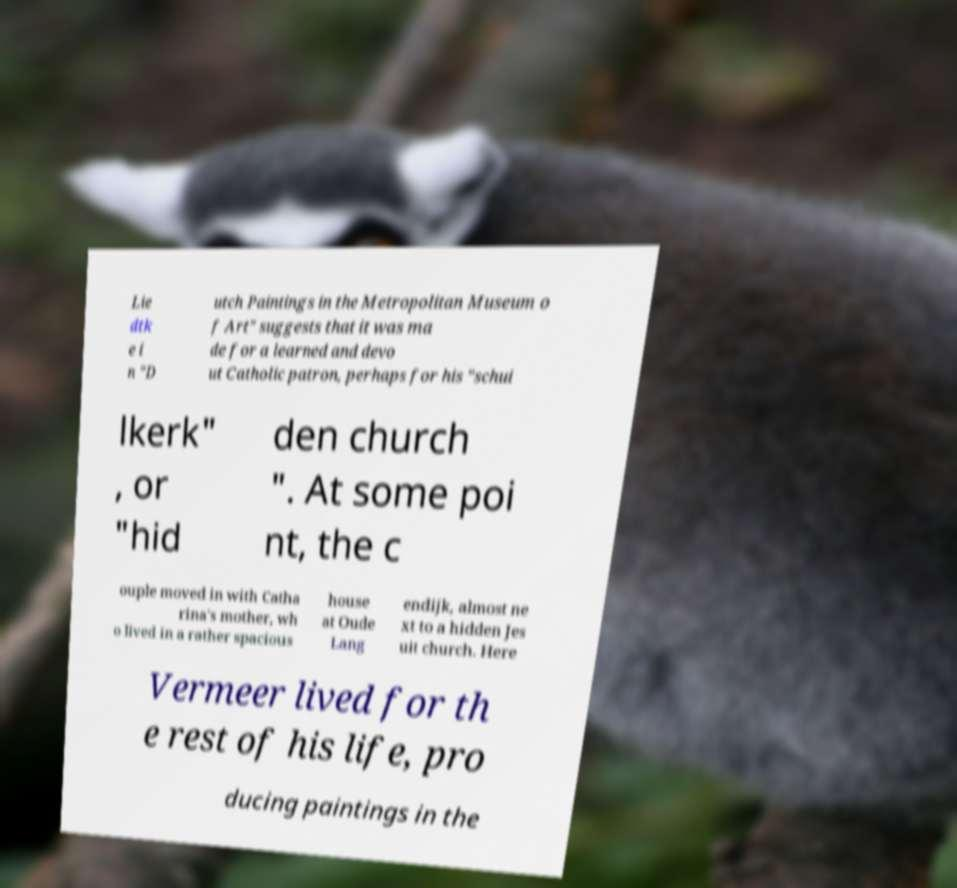For documentation purposes, I need the text within this image transcribed. Could you provide that? Lie dtk e i n "D utch Paintings in the Metropolitan Museum o f Art" suggests that it was ma de for a learned and devo ut Catholic patron, perhaps for his "schui lkerk" , or "hid den church ". At some poi nt, the c ouple moved in with Catha rina's mother, wh o lived in a rather spacious house at Oude Lang endijk, almost ne xt to a hidden Jes uit church. Here Vermeer lived for th e rest of his life, pro ducing paintings in the 